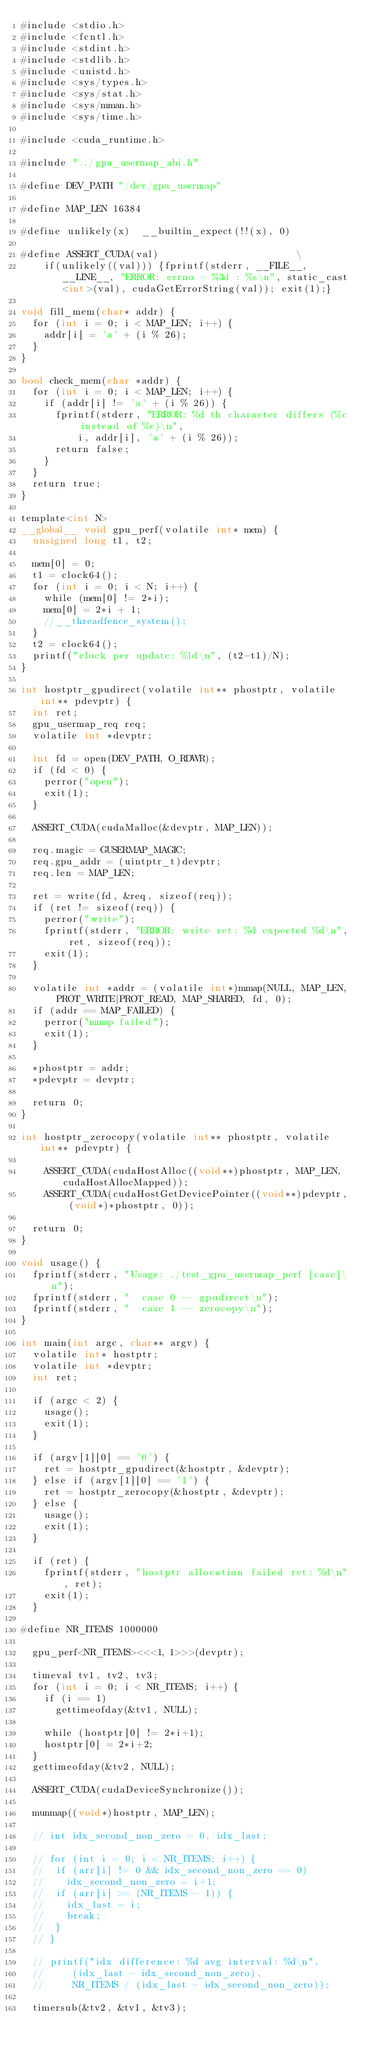<code> <loc_0><loc_0><loc_500><loc_500><_Cuda_>#include <stdio.h>
#include <fcntl.h>
#include <stdint.h>
#include <stdlib.h>
#include <unistd.h>
#include <sys/types.h>
#include <sys/stat.h>
#include <sys/mman.h>
#include <sys/time.h>

#include <cuda_runtime.h>

#include "../gpu_usermap_abi.h"

#define DEV_PATH "/dev/gpu_usermap"

#define MAP_LEN 16384

#define unlikely(x)  __builtin_expect(!!(x), 0)

#define ASSERT_CUDA(val)												\
    if(unlikely((val))) {fprintf(stderr, __FILE__, __LINE__, "ERROR: errno = %3d : %s\n", static_cast<int>(val), cudaGetErrorString(val)); exit(1);}

void fill_mem(char* addr) {
	for (int i = 0; i < MAP_LEN; i++) {
		addr[i] = 'a' + (i % 26);
	}
}

bool check_mem(char *addr) {
	for (int i = 0; i < MAP_LEN; i++) {
		if (addr[i] != 'a' + (i % 26)) {
			fprintf(stderr, "ERROR: %d th character differs (%c instead of %c)\n",
					i, addr[i], 'a' + (i % 26));
			return false;
		}
	}
	return true;
}

template<int N>
__global__ void gpu_perf(volatile int* mem) {
	unsigned long t1, t2;

	mem[0] = 0;
	t1 = clock64();
	for (int i = 0; i < N; i++) {
		while (mem[0] != 2*i);
		mem[0] = 2*i + 1;
		//__threadfence_system();
	}
	t2 = clock64();
	printf("clock per update: %ld\n", (t2-t1)/N);
}

int hostptr_gpudirect(volatile int** phostptr, volatile int** pdevptr) {
	int ret;
	gpu_usermap_req req;
	volatile int *devptr;

	int fd = open(DEV_PATH, O_RDWR);
	if (fd < 0) {
		perror("open");
		exit(1);
	}

	ASSERT_CUDA(cudaMalloc(&devptr, MAP_LEN));
	
	req.magic = GUSERMAP_MAGIC;
	req.gpu_addr = (uintptr_t)devptr;
	req.len = MAP_LEN;

	ret = write(fd, &req, sizeof(req));
	if (ret != sizeof(req)) {
		perror("write");
		fprintf(stderr, "ERROR: write ret: %d expected %d\n", ret, sizeof(req));
		exit(1);
	}
	
	volatile int *addr = (volatile int*)mmap(NULL, MAP_LEN, PROT_WRITE|PROT_READ, MAP_SHARED, fd, 0);
	if (addr == MAP_FAILED) {
		perror("mmap failed");
		exit(1);
	}

	*phostptr = addr;
	*pdevptr = devptr;

	return 0;
}

int hostptr_zerocopy(volatile int** phostptr, volatile int** pdevptr) {

    ASSERT_CUDA(cudaHostAlloc((void**)phostptr, MAP_LEN, cudaHostAllocMapped));
    ASSERT_CUDA(cudaHostGetDevicePointer((void**)pdevptr, (void*)*phostptr, 0));
	
	return 0;
}

void usage() {
	fprintf(stderr, "Usage: ./test_gpu_usermap_perf [case]\n");
	fprintf(stderr, "  case 0 -- gpudirect\n");
	fprintf(stderr, "  case 1 -- zerocopy\n");
}

int main(int argc, char** argv) {
	volatile int* hostptr;
	volatile int *devptr;
	int ret;

	if (argc < 2) {
		usage();
		exit(1);
	}

	if (argv[1][0] == '0') {
		ret = hostptr_gpudirect(&hostptr, &devptr);
	} else if (argv[1][0] == '1') {
		ret = hostptr_zerocopy(&hostptr, &devptr);
	} else {
		usage();
		exit(1);
	}

	if (ret) {
		fprintf(stderr, "hostptr allocation failed ret: %d\n", ret);
		exit(1);
	}

#define NR_ITEMS 1000000

	gpu_perf<NR_ITEMS><<<1, 1>>>(devptr);

	timeval tv1, tv2, tv3;
	for (int i = 0; i < NR_ITEMS; i++) {
		if (i == 1)
			gettimeofday(&tv1, NULL);
			
		while (hostptr[0] != 2*i+1);
		hostptr[0] = 2*i+2;
	}
	gettimeofday(&tv2, NULL);
	
	ASSERT_CUDA(cudaDeviceSynchronize());

	munmap((void*)hostptr, MAP_LEN);

	// int idx_second_non_zero = 0, idx_last;

	// for (int i = 0; i < NR_ITEMS; i++) {
	// 	if (arr[i] != 0 && idx_second_non_zero == 0)
	// 		idx_second_non_zero = i+1;
	// 	if (arr[i] >= (NR_ITEMS - 1)) {
	// 		idx_last = i;
	// 		break;
	// 	}
	// }

	// printf("idx difference: %d avg interval: %d\n",
	// 	   (idx_last - idx_second_non_zero),
	// 	   NR_ITEMS / (idx_last - idx_second_non_zero));

	timersub(&tv2, &tv1, &tv3);
</code> 